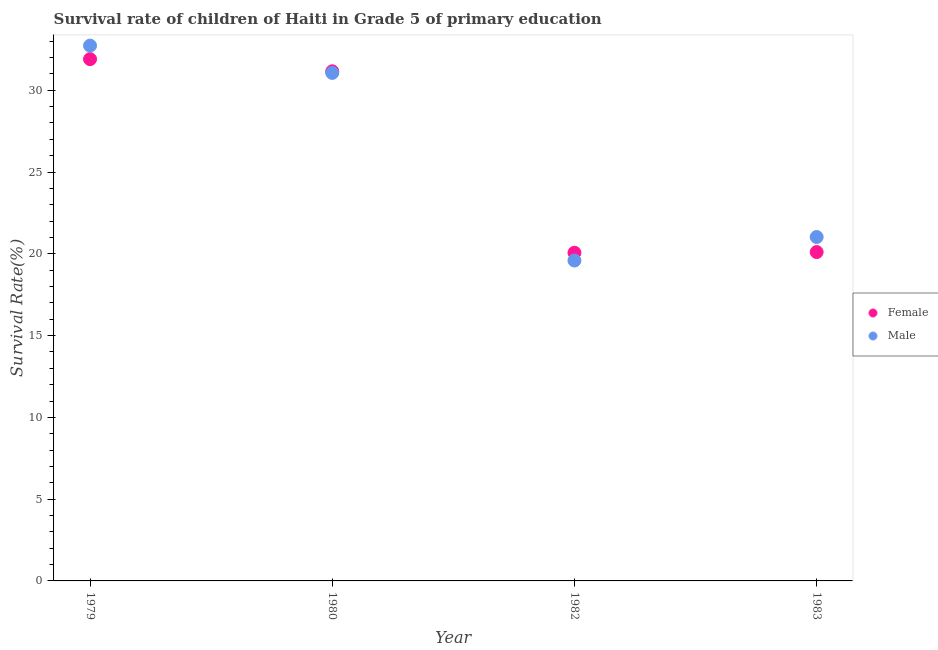Is the number of dotlines equal to the number of legend labels?
Provide a short and direct response. Yes. What is the survival rate of male students in primary education in 1980?
Offer a very short reply. 31.06. Across all years, what is the maximum survival rate of female students in primary education?
Give a very brief answer. 31.9. Across all years, what is the minimum survival rate of male students in primary education?
Make the answer very short. 19.59. In which year was the survival rate of female students in primary education maximum?
Offer a terse response. 1979. In which year was the survival rate of male students in primary education minimum?
Offer a terse response. 1982. What is the total survival rate of male students in primary education in the graph?
Provide a short and direct response. 104.41. What is the difference between the survival rate of male students in primary education in 1979 and that in 1983?
Your answer should be compact. 11.7. What is the difference between the survival rate of male students in primary education in 1983 and the survival rate of female students in primary education in 1980?
Provide a succinct answer. -10.13. What is the average survival rate of female students in primary education per year?
Your answer should be very brief. 25.81. In the year 1979, what is the difference between the survival rate of male students in primary education and survival rate of female students in primary education?
Your answer should be compact. 0.83. What is the ratio of the survival rate of female students in primary education in 1979 to that in 1980?
Provide a short and direct response. 1.02. Is the survival rate of male students in primary education in 1979 less than that in 1980?
Give a very brief answer. No. What is the difference between the highest and the second highest survival rate of female students in primary education?
Give a very brief answer. 0.74. What is the difference between the highest and the lowest survival rate of female students in primary education?
Your response must be concise. 11.84. In how many years, is the survival rate of male students in primary education greater than the average survival rate of male students in primary education taken over all years?
Your answer should be very brief. 2. Is the survival rate of male students in primary education strictly greater than the survival rate of female students in primary education over the years?
Your answer should be compact. No. Is the survival rate of male students in primary education strictly less than the survival rate of female students in primary education over the years?
Keep it short and to the point. No. How many dotlines are there?
Your response must be concise. 2. How many years are there in the graph?
Provide a short and direct response. 4. Are the values on the major ticks of Y-axis written in scientific E-notation?
Your answer should be compact. No. Does the graph contain any zero values?
Make the answer very short. No. Does the graph contain grids?
Your response must be concise. No. Where does the legend appear in the graph?
Ensure brevity in your answer.  Center right. What is the title of the graph?
Make the answer very short. Survival rate of children of Haiti in Grade 5 of primary education. Does "Largest city" appear as one of the legend labels in the graph?
Ensure brevity in your answer.  No. What is the label or title of the Y-axis?
Provide a succinct answer. Survival Rate(%). What is the Survival Rate(%) in Female in 1979?
Your answer should be very brief. 31.9. What is the Survival Rate(%) in Male in 1979?
Keep it short and to the point. 32.73. What is the Survival Rate(%) of Female in 1980?
Provide a succinct answer. 31.16. What is the Survival Rate(%) in Male in 1980?
Give a very brief answer. 31.06. What is the Survival Rate(%) in Female in 1982?
Keep it short and to the point. 20.07. What is the Survival Rate(%) of Male in 1982?
Give a very brief answer. 19.59. What is the Survival Rate(%) in Female in 1983?
Offer a terse response. 20.11. What is the Survival Rate(%) in Male in 1983?
Make the answer very short. 21.03. Across all years, what is the maximum Survival Rate(%) of Female?
Your answer should be very brief. 31.9. Across all years, what is the maximum Survival Rate(%) in Male?
Make the answer very short. 32.73. Across all years, what is the minimum Survival Rate(%) of Female?
Your answer should be compact. 20.07. Across all years, what is the minimum Survival Rate(%) of Male?
Offer a terse response. 19.59. What is the total Survival Rate(%) of Female in the graph?
Ensure brevity in your answer.  103.23. What is the total Survival Rate(%) in Male in the graph?
Offer a very short reply. 104.41. What is the difference between the Survival Rate(%) in Female in 1979 and that in 1980?
Provide a succinct answer. 0.74. What is the difference between the Survival Rate(%) of Male in 1979 and that in 1980?
Ensure brevity in your answer.  1.67. What is the difference between the Survival Rate(%) of Female in 1979 and that in 1982?
Ensure brevity in your answer.  11.84. What is the difference between the Survival Rate(%) in Male in 1979 and that in 1982?
Ensure brevity in your answer.  13.14. What is the difference between the Survival Rate(%) in Female in 1979 and that in 1983?
Make the answer very short. 11.8. What is the difference between the Survival Rate(%) in Male in 1979 and that in 1983?
Ensure brevity in your answer.  11.7. What is the difference between the Survival Rate(%) of Female in 1980 and that in 1982?
Provide a succinct answer. 11.09. What is the difference between the Survival Rate(%) of Male in 1980 and that in 1982?
Provide a short and direct response. 11.47. What is the difference between the Survival Rate(%) in Female in 1980 and that in 1983?
Give a very brief answer. 11.05. What is the difference between the Survival Rate(%) of Male in 1980 and that in 1983?
Offer a very short reply. 10.03. What is the difference between the Survival Rate(%) in Female in 1982 and that in 1983?
Make the answer very short. -0.04. What is the difference between the Survival Rate(%) of Male in 1982 and that in 1983?
Make the answer very short. -1.44. What is the difference between the Survival Rate(%) in Female in 1979 and the Survival Rate(%) in Male in 1980?
Your response must be concise. 0.84. What is the difference between the Survival Rate(%) in Female in 1979 and the Survival Rate(%) in Male in 1982?
Offer a terse response. 12.31. What is the difference between the Survival Rate(%) of Female in 1979 and the Survival Rate(%) of Male in 1983?
Provide a short and direct response. 10.88. What is the difference between the Survival Rate(%) in Female in 1980 and the Survival Rate(%) in Male in 1982?
Provide a short and direct response. 11.57. What is the difference between the Survival Rate(%) of Female in 1980 and the Survival Rate(%) of Male in 1983?
Give a very brief answer. 10.13. What is the difference between the Survival Rate(%) of Female in 1982 and the Survival Rate(%) of Male in 1983?
Your response must be concise. -0.96. What is the average Survival Rate(%) of Female per year?
Offer a terse response. 25.81. What is the average Survival Rate(%) of Male per year?
Give a very brief answer. 26.1. In the year 1979, what is the difference between the Survival Rate(%) of Female and Survival Rate(%) of Male?
Your answer should be very brief. -0.83. In the year 1980, what is the difference between the Survival Rate(%) of Female and Survival Rate(%) of Male?
Keep it short and to the point. 0.1. In the year 1982, what is the difference between the Survival Rate(%) of Female and Survival Rate(%) of Male?
Make the answer very short. 0.47. In the year 1983, what is the difference between the Survival Rate(%) of Female and Survival Rate(%) of Male?
Offer a terse response. -0.92. What is the ratio of the Survival Rate(%) in Female in 1979 to that in 1980?
Provide a short and direct response. 1.02. What is the ratio of the Survival Rate(%) in Male in 1979 to that in 1980?
Your answer should be very brief. 1.05. What is the ratio of the Survival Rate(%) of Female in 1979 to that in 1982?
Provide a succinct answer. 1.59. What is the ratio of the Survival Rate(%) in Male in 1979 to that in 1982?
Your response must be concise. 1.67. What is the ratio of the Survival Rate(%) of Female in 1979 to that in 1983?
Ensure brevity in your answer.  1.59. What is the ratio of the Survival Rate(%) of Male in 1979 to that in 1983?
Your answer should be very brief. 1.56. What is the ratio of the Survival Rate(%) in Female in 1980 to that in 1982?
Offer a terse response. 1.55. What is the ratio of the Survival Rate(%) in Male in 1980 to that in 1982?
Your answer should be very brief. 1.59. What is the ratio of the Survival Rate(%) in Female in 1980 to that in 1983?
Your answer should be compact. 1.55. What is the ratio of the Survival Rate(%) of Male in 1980 to that in 1983?
Offer a terse response. 1.48. What is the ratio of the Survival Rate(%) of Female in 1982 to that in 1983?
Keep it short and to the point. 1. What is the ratio of the Survival Rate(%) in Male in 1982 to that in 1983?
Offer a terse response. 0.93. What is the difference between the highest and the second highest Survival Rate(%) of Female?
Provide a succinct answer. 0.74. What is the difference between the highest and the second highest Survival Rate(%) in Male?
Keep it short and to the point. 1.67. What is the difference between the highest and the lowest Survival Rate(%) in Female?
Your answer should be very brief. 11.84. What is the difference between the highest and the lowest Survival Rate(%) of Male?
Offer a very short reply. 13.14. 